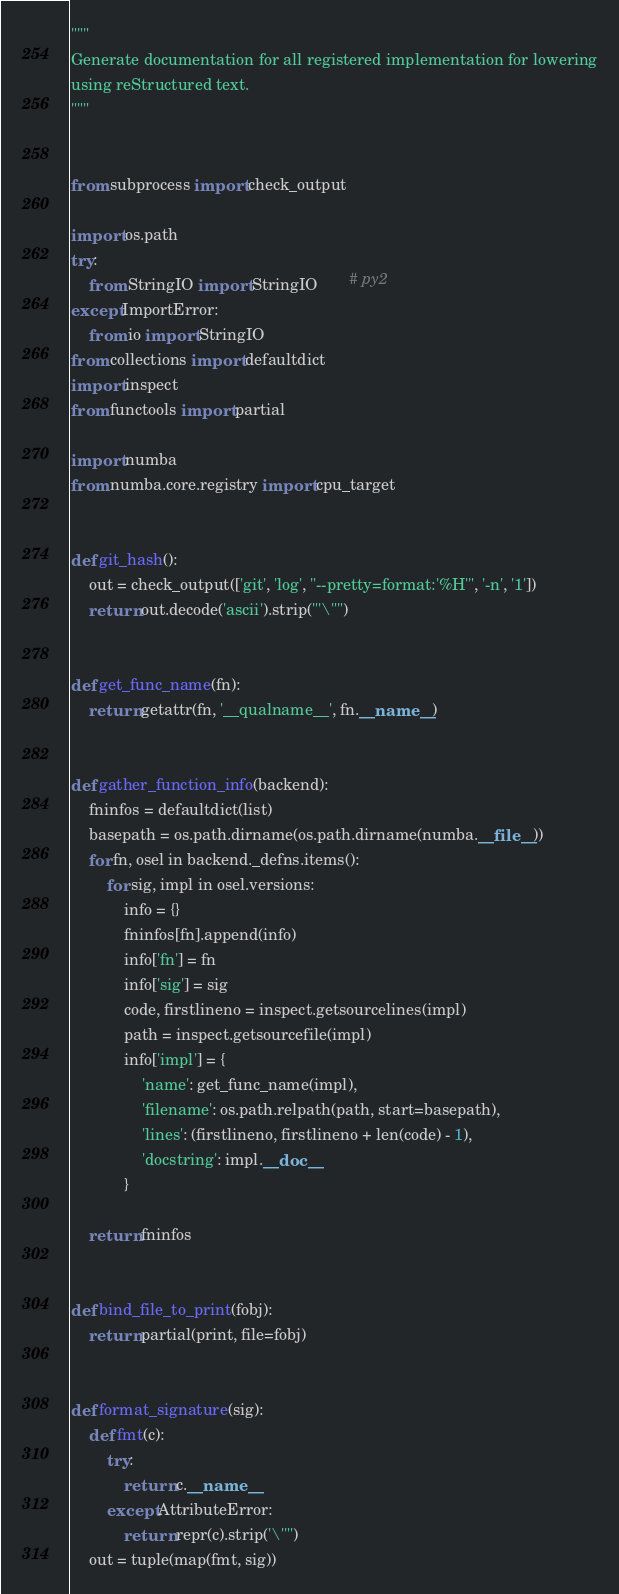<code> <loc_0><loc_0><loc_500><loc_500><_Python_>"""
Generate documentation for all registered implementation for lowering
using reStructured text.
"""


from subprocess import check_output

import os.path
try:
    from StringIO import StringIO       # py2
except ImportError:
    from io import StringIO
from collections import defaultdict
import inspect
from functools import partial

import numba
from numba.core.registry import cpu_target


def git_hash():
    out = check_output(['git', 'log', "--pretty=format:'%H'", '-n', '1'])
    return out.decode('ascii').strip("'\"")


def get_func_name(fn):
    return getattr(fn, '__qualname__', fn.__name__)


def gather_function_info(backend):
    fninfos = defaultdict(list)
    basepath = os.path.dirname(os.path.dirname(numba.__file__))
    for fn, osel in backend._defns.items():
        for sig, impl in osel.versions:
            info = {}
            fninfos[fn].append(info)
            info['fn'] = fn
            info['sig'] = sig
            code, firstlineno = inspect.getsourcelines(impl)
            path = inspect.getsourcefile(impl)
            info['impl'] = {
                'name': get_func_name(impl),
                'filename': os.path.relpath(path, start=basepath),
                'lines': (firstlineno, firstlineno + len(code) - 1),
                'docstring': impl.__doc__
            }

    return fninfos


def bind_file_to_print(fobj):
    return partial(print, file=fobj)


def format_signature(sig):
    def fmt(c):
        try:
            return c.__name__
        except AttributeError:
            return repr(c).strip('\'"')
    out = tuple(map(fmt, sig))</code> 